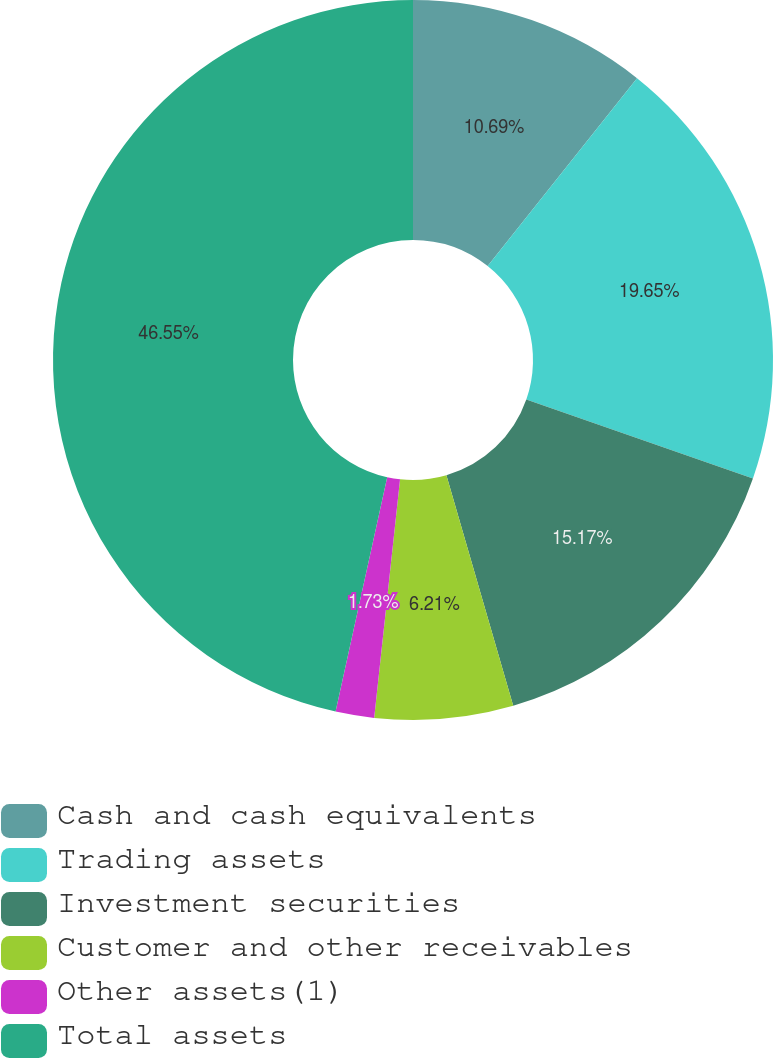Convert chart. <chart><loc_0><loc_0><loc_500><loc_500><pie_chart><fcel>Cash and cash equivalents<fcel>Trading assets<fcel>Investment securities<fcel>Customer and other receivables<fcel>Other assets(1)<fcel>Total assets<nl><fcel>10.69%<fcel>19.65%<fcel>15.17%<fcel>6.21%<fcel>1.73%<fcel>46.55%<nl></chart> 